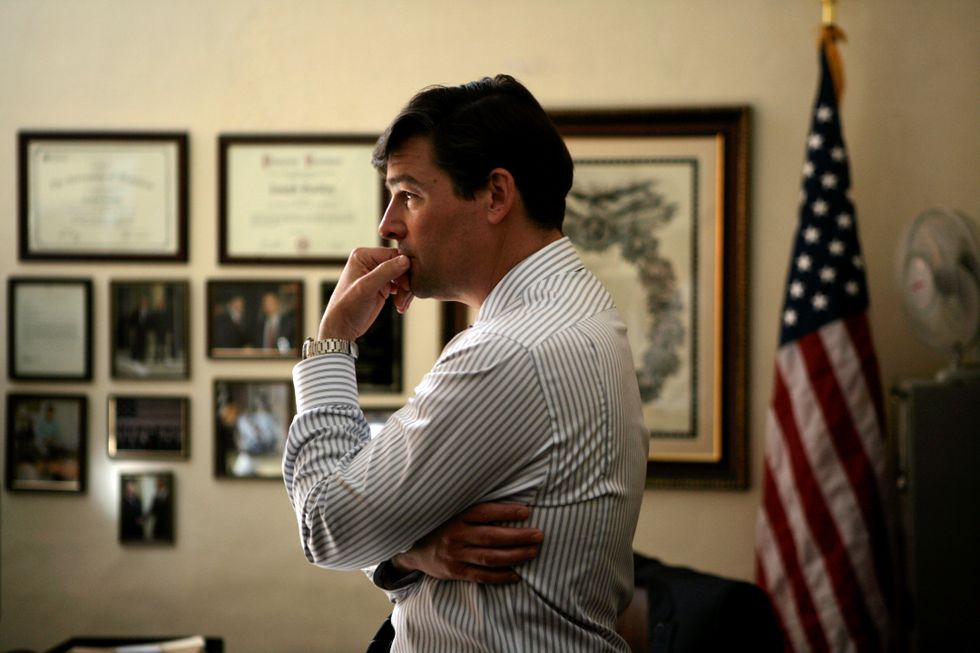Can you elaborate on the elements of the picture provided? The image features a man standing in what appears to be an office or study room. He is deep in thought, with his right hand resting on his chin and his left arm folded across his body. The man is dressed in a white and blue striped shirt. On the wall behind him, there are various certificates and framed photos, giving the room a professional atmosphere. An American flag is also visible, adding a patriotic element to the setting. 